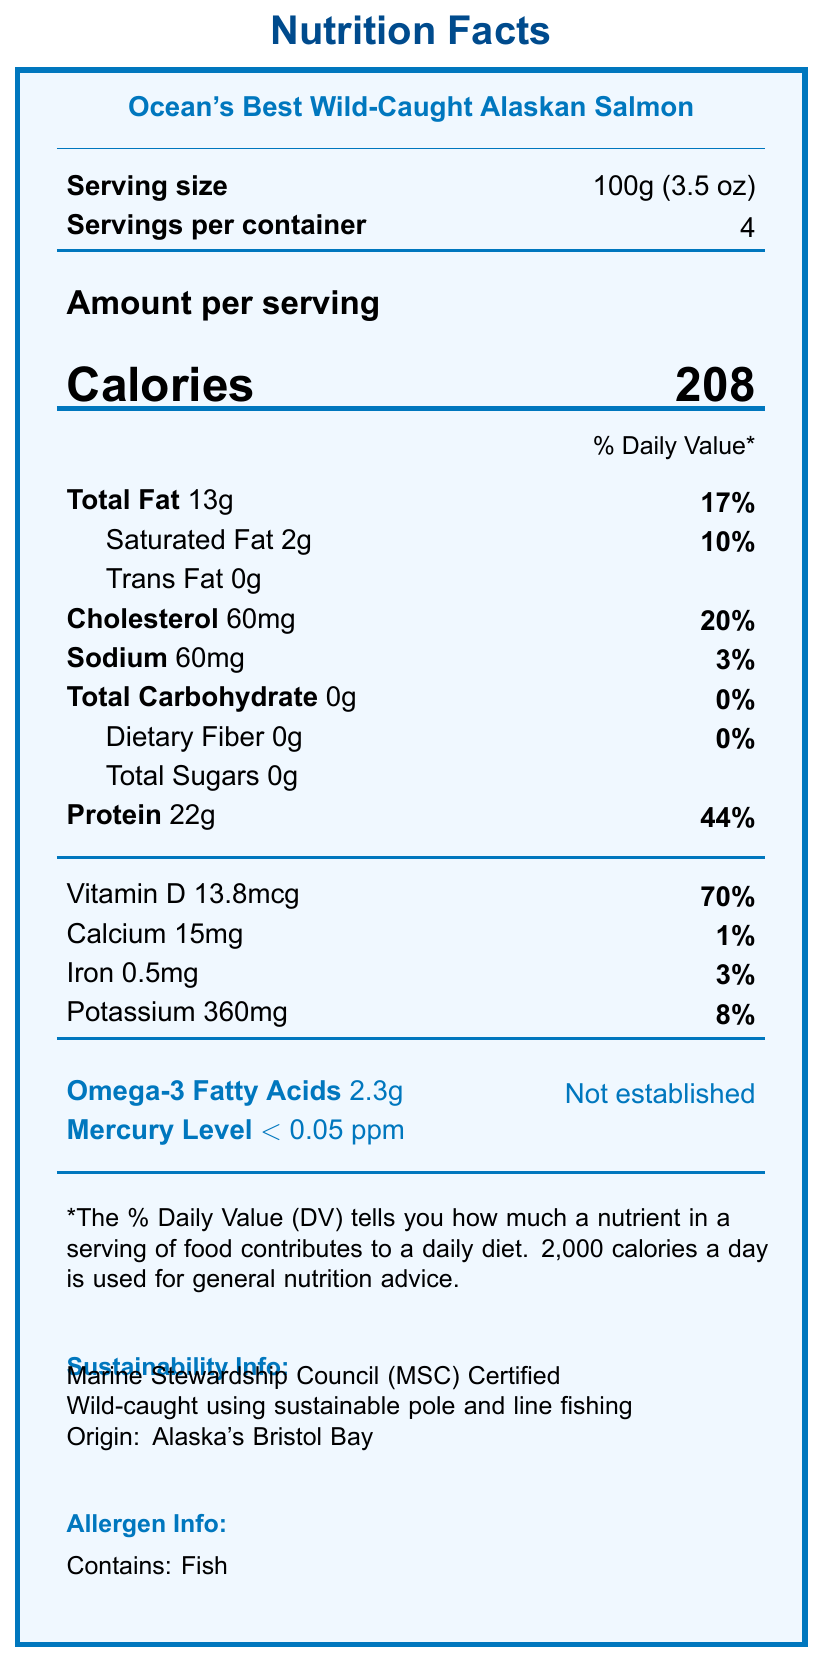what is the serving size? The serving size is listed right below the product name and is "100g (3.5 oz)".
Answer: 100g (3.5 oz) how many calories are there per serving? The calories per serving are mentioned right in the middle under "Amount per serving" and are "208".
Answer: 208 what is the total fat content in a serving? The total fat content is listed in the 'Amount per serving' section and is "13g".
Answer: 13g how much protein does each serving provide? The protein content per serving is listed as "22g".
Answer: 22g what percentage of the daily value of vitamin D is in each serving? The percentage of the daily value of vitamin D is listed as "70%" next to "Vitamin D 13.8mcg".
Answer: 70% which certification does the product have for sustainability? A. USDA Organic B. Rainforest Alliance Certified C. Marine Stewardship Council (MSC) Certified D. Fair Trade Certified The sustainability info section mentions that the product is "Marine Stewardship Council (MSC) Certified".
Answer: C what is the fishing method used for sourcing this product? A. Trawling B. Sustainable pole and line fishing C. Aquaculture D. Longline fishing The sustainability info section states that the product is "Wild-caught using sustainable pole and line fishing".
Answer: B what minerals are noted on the label, and how much of each is provided per serving? Calcium is 15mg, Iron is 0.5mg, and Potassium is 360mg as listed in the vitamins and minerals section.
Answer: Calcium 15mg, Iron 0.5mg, Potassium 360mg is this product high in mercury? The label indicates that the mercury level is "< 0.05 ppm" which is considered low.
Answer: No describe the main idea of the document. The label includes extensive nutritional breakdowns, serving sizes, health benefits, sustainability certifications, and allergen information about the product.
Answer: The document is a Nutrition Facts Label for "Ocean's Best Wild-Caught Alaskan Salmon". It provides detailed nutritional information per serving, emphasizes its high omega-3 content and low mercury levels, and highlights its sustainability credentials and health benefits. what is the carbon footprint mentioned for this product? The environmental impact section notes the carbon footprint as "2.5 kg CO2e per kg of product".
Answer: 2.5 kg CO2e per kg of product how long should the product be consumed after opening? The storage instructions specify to consume the product within "2 days of opening".
Answer: 2 days what is the daily value percentage of cholesterol per serving? The cholesterol daily value percentage is listed as "20%" next to "Cholesterol 60mg".
Answer: 20% what does the document say about the product's impact on freshwater usage? The environmental impact section mentions "Minimal freshwater impact due to wild-caught nature".
Answer: Minimal freshwater impact due to wild-caught nature based on the document, what are the calorie requirements the % daily value is based on? The note at the bottom of the nutrition facts states that the % daily value is based on "2,000 calories a day".
Answer: 2000 calories a day where is the product sourced from? The sustainability info mentions that the origin is "Alaska's Bristol Bay".
Answer: Alaska's Bristol Bay can you determine the exact date on the package from this document? The storage instructions mention consuming by the date on the package, but the exact date is not specified in the provided information.
Answer: Cannot be determined 